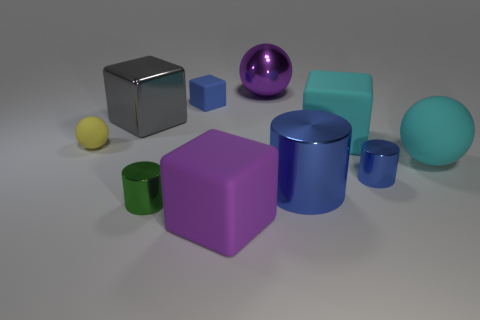There is a tiny matte object that is the same shape as the big gray object; what color is it?
Offer a terse response. Blue. How many matte cylinders are the same color as the big metallic cylinder?
Offer a terse response. 0. There is a block that is in front of the small green cylinder; is its size the same as the purple thing behind the small green cylinder?
Give a very brief answer. Yes. There is a gray metal cube; does it have the same size as the matte thing that is behind the gray object?
Offer a terse response. No. How big is the cyan block?
Your answer should be compact. Large. There is a large ball that is made of the same material as the small sphere; what color is it?
Offer a very short reply. Cyan. What number of big purple balls are the same material as the large gray thing?
Provide a succinct answer. 1. How many things are yellow shiny things or large metal things that are behind the gray object?
Keep it short and to the point. 1. Is the cyan thing that is behind the cyan ball made of the same material as the tiny yellow thing?
Make the answer very short. Yes. What is the color of the matte sphere that is the same size as the blue rubber thing?
Give a very brief answer. Yellow. 